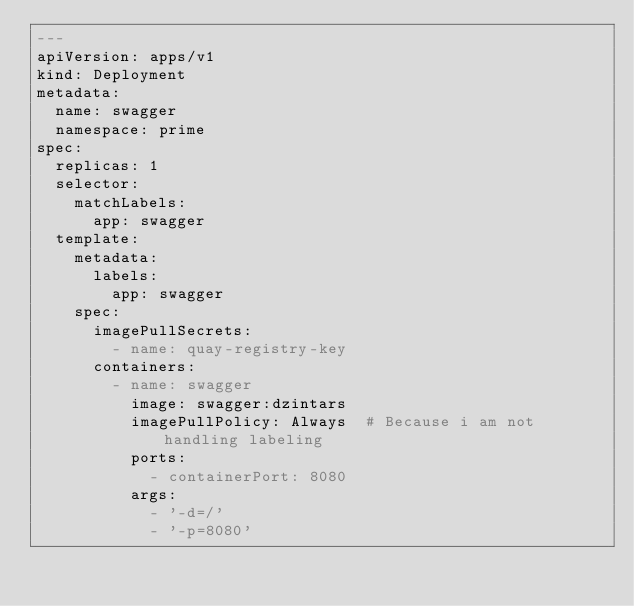Convert code to text. <code><loc_0><loc_0><loc_500><loc_500><_YAML_>---
apiVersion: apps/v1
kind: Deployment
metadata:
  name: swagger
  namespace: prime
spec:
  replicas: 1
  selector:
    matchLabels:
      app: swagger
  template:
    metadata:
      labels:
        app: swagger
    spec:
      imagePullSecrets:
        - name: quay-registry-key
      containers:
        - name: swagger
          image: swagger:dzintars
          imagePullPolicy: Always  # Because i am not handling labeling
          ports:
            - containerPort: 8080
          args:
            - '-d=/'
            - '-p=8080'
</code> 